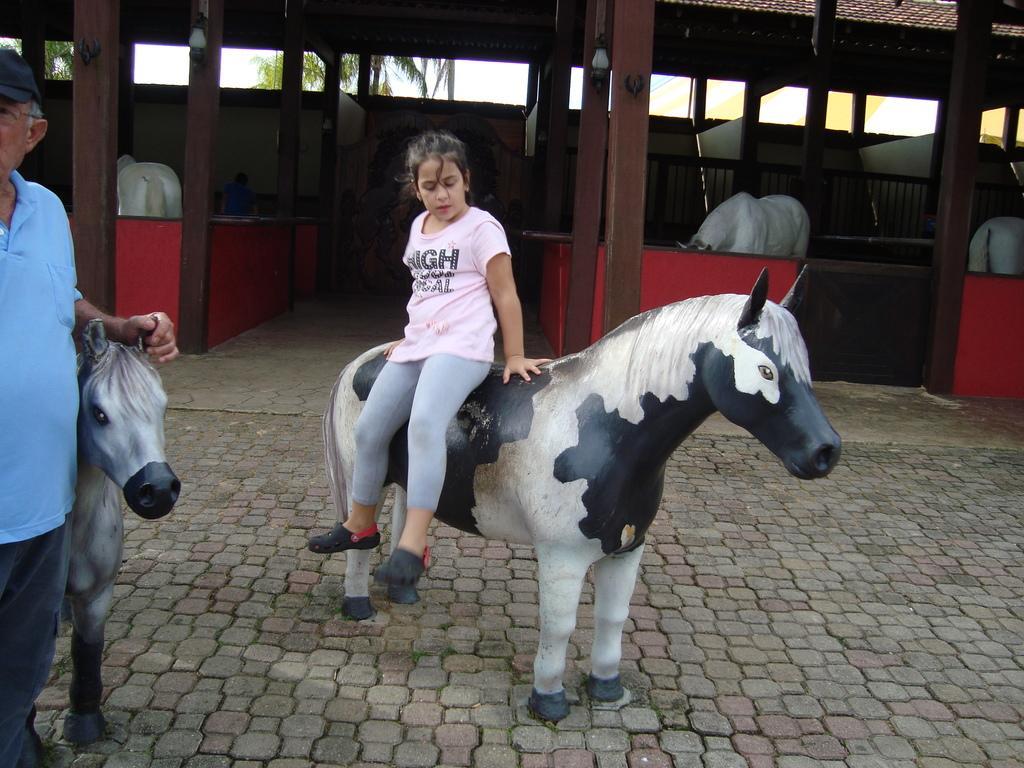Can you describe this image briefly? In this image we can see a child sitting on the toy horse. On the left side of the image we can see a man wearing blue t shirt is touching the toy horse. In the background we can see a shed. 